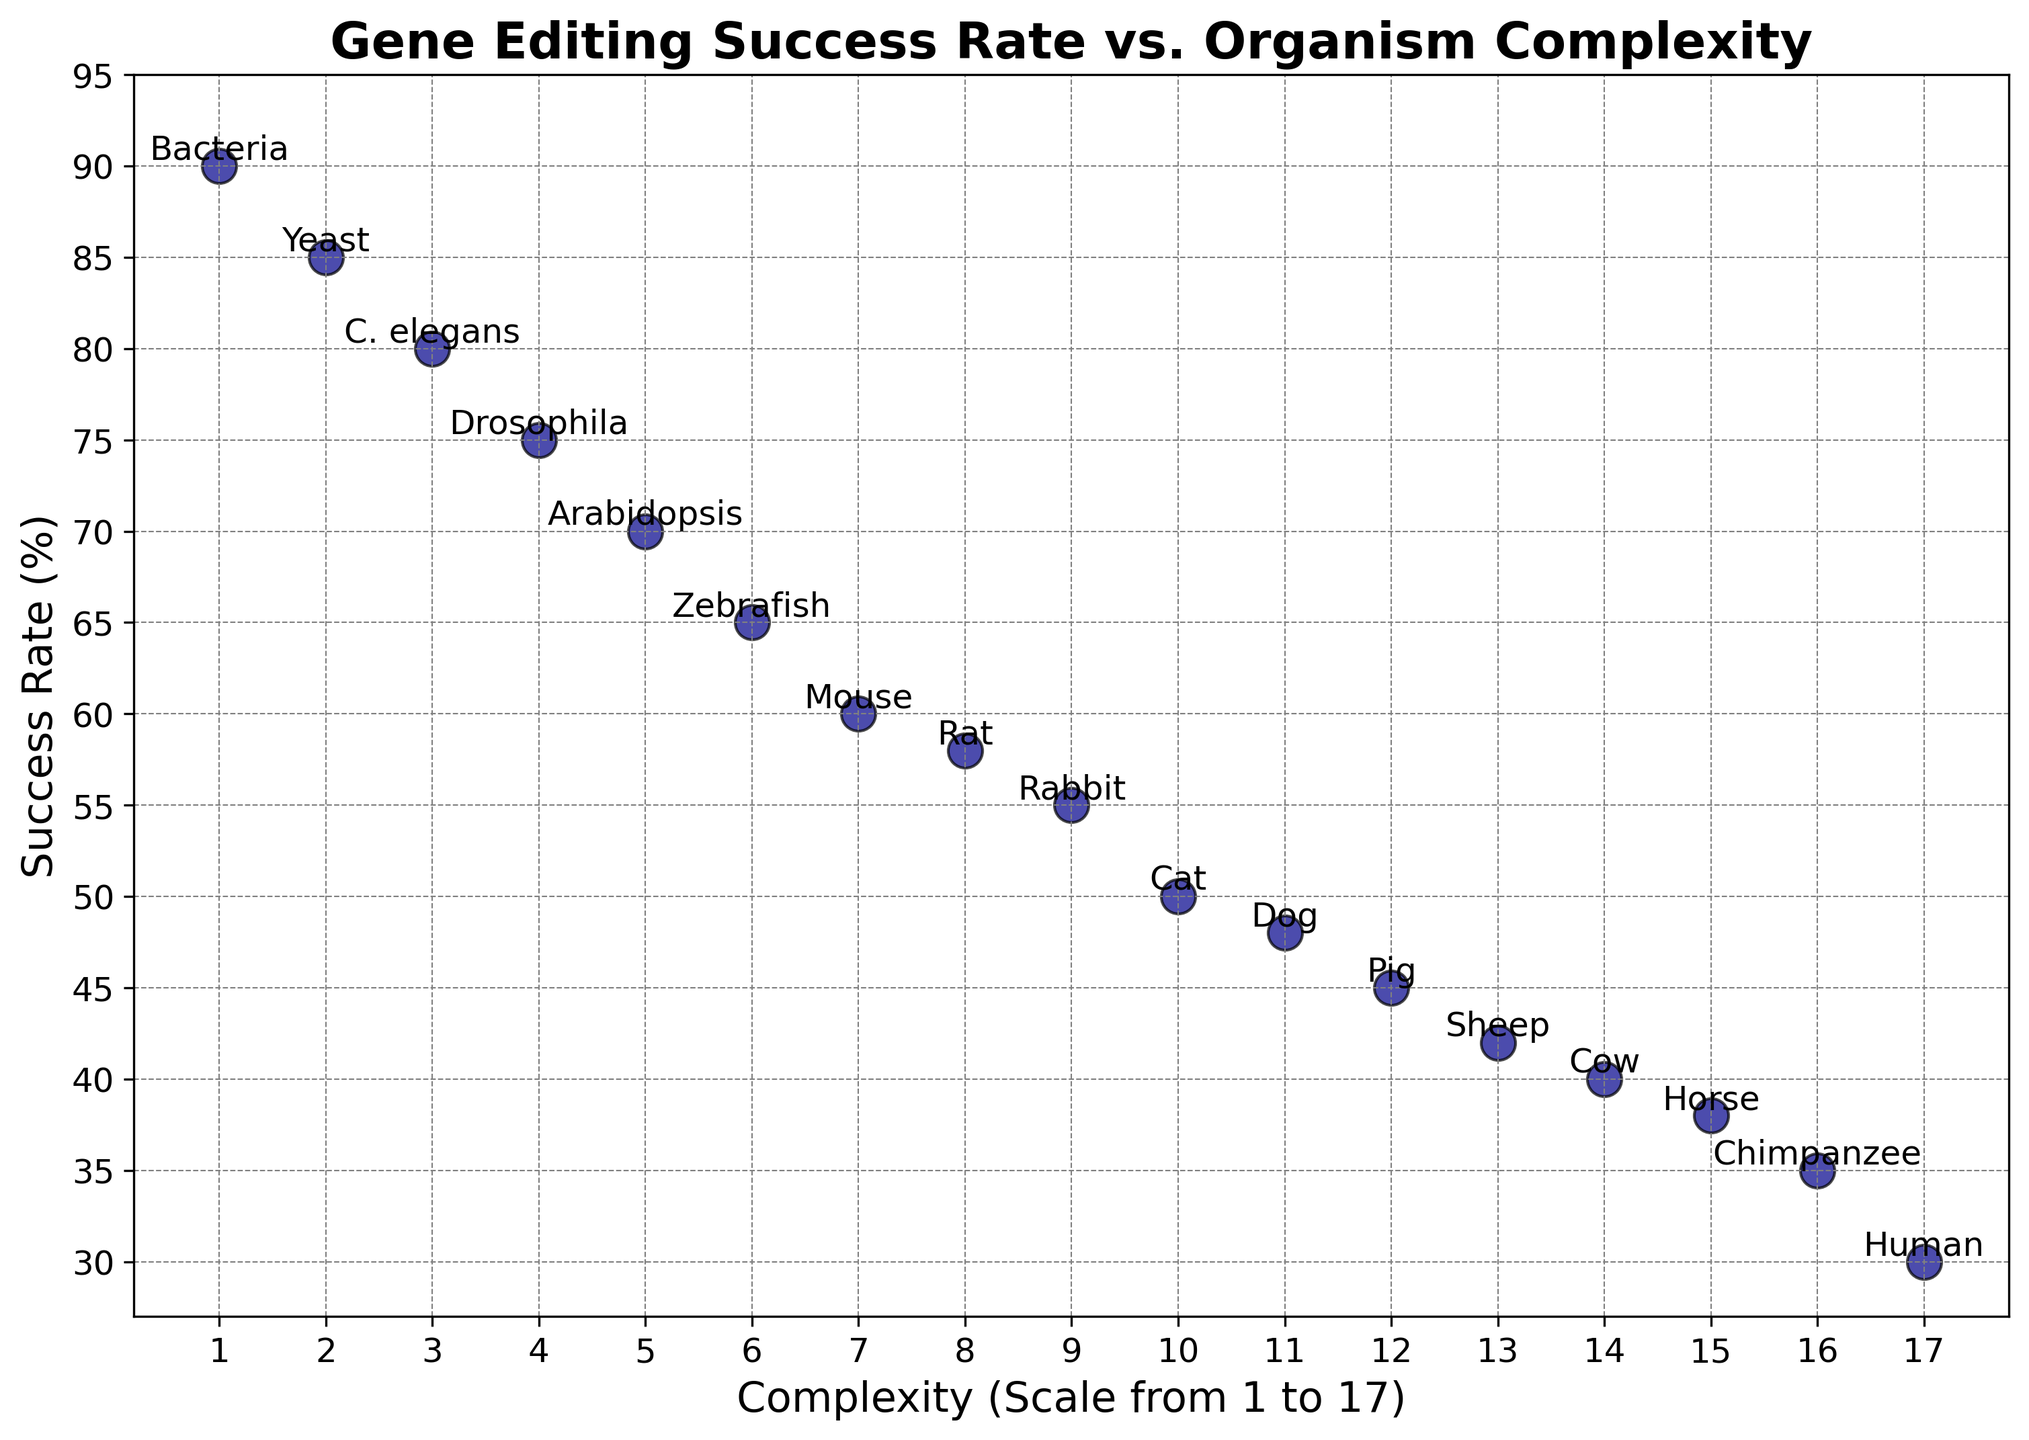What's the average success rate for organisms with complexity levels from 1 to 5? To find the average success rate, sum up the success rates for organisms with complexity levels from 1 to 5 (i.e., Bacteria, Yeast, C. elegans, Drosophila, and Arabidopsis) and divide by the number of organisms. The success rates are 90, 85, 80, 75, and 70. The sum is 400. Divide by 5 to get the average: 400 / 5 = 80
Answer: 80 Which organism has the highest gene editing success rate? Look for the data point with the highest success rate on the vertical axis. The organism with the highest success rate is Bacteria with a success rate of 90%.
Answer: Bacteria Which organism has the lowest gene editing success rate? Look for the data point with the lowest success rate on the vertical axis. The organism with the lowest success rate is Human with a success rate of 30%.
Answer: Human How does the success rate change as the complexity level increases from 1 to 4? Observe the trend in the scatter plot as the complexity increases from 1 (Bacteria) to 4 (Drosophila). The success rates for these organisms are 90%, 85%, 80%, and 75% respectively. There is a decreasing trend in success rate.
Answer: Decreases By how many percentage points is the success rate of Chimpanzee greater than the success rate of Human? Subtract the success rate of Human (30%) from the success rate of Chimpanzee (35%). 35% - 30% = 5 percentage points
Answer: 5 What is the median success rate for the given organisms? Sort the success rates in ascending order and find the middle value. The success rates in order: 30, 35, 38, 40, 42, 45, 48, 50, 55, 58, 60, 65, 70, 75, 80, 85, 90. The middle values are 48 and 50. The median is the average of these two values: (48 + 50) / 2 = 49
Answer: 49 Is the success rate higher for Cat or for Pig? Compare the success rates of Cat and Pig. Cat has a success rate of 50% and Pig has a success rate of 45%. Therefore, the success rate is higher for Cat.
Answer: Cat What is the difference in success rates between the simplest (Bacteria) and the most complex (Human) organisms? Subtract the success rate of Human (30%) from the success rate of Bacteria (90%). 90% - 30% = 60 percentage points.
Answer: 60 